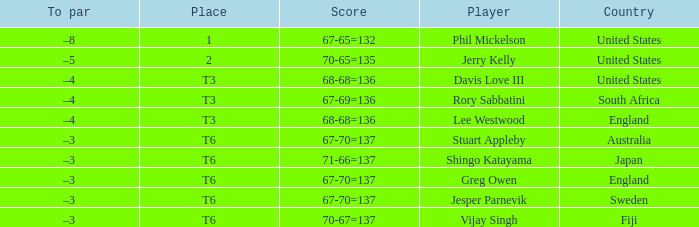Name the score for fiji 70-67=137. 